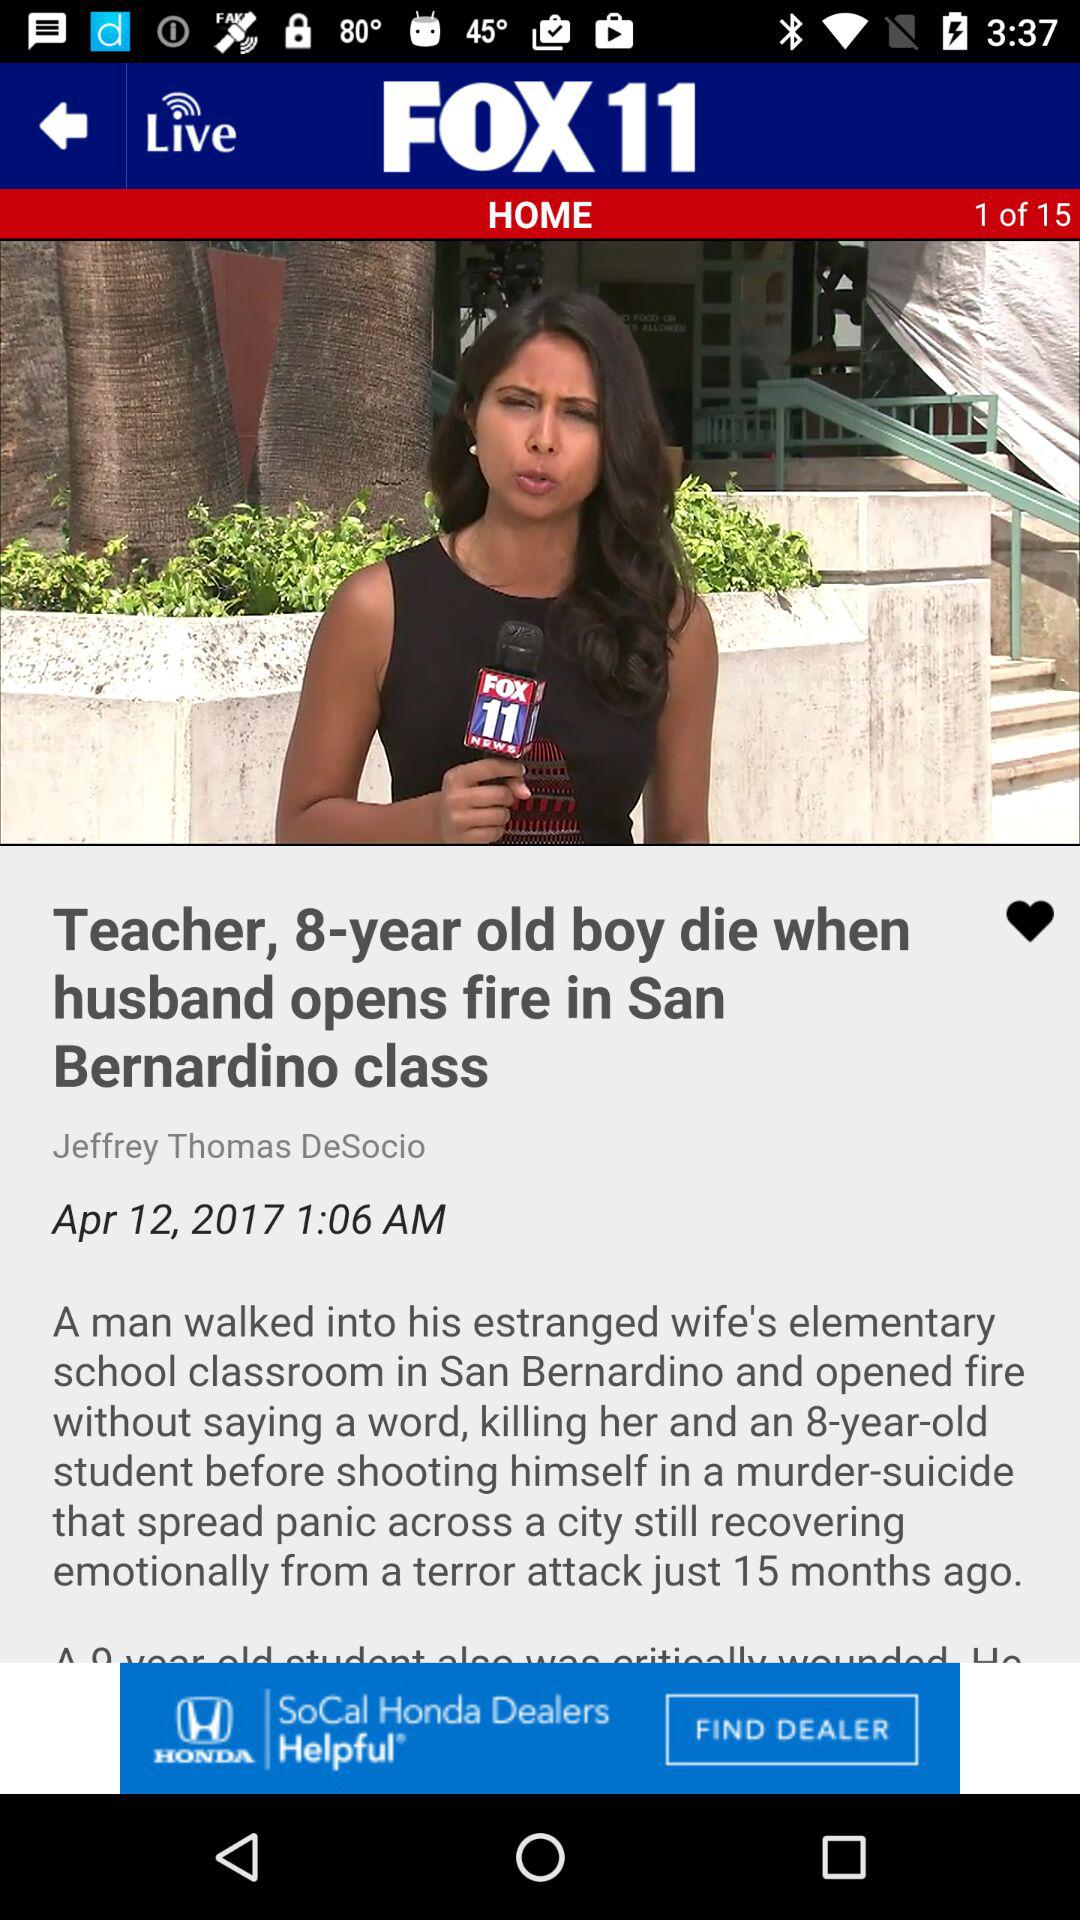When was the news "Teacher, 8-year old boy die when husband opens fire in San Bernardino class" published? The news "Teacher, 8-year old boy die when husband opens fire in San Bernardino class" was published on April 12, 2017 at 1:06 a.m. 